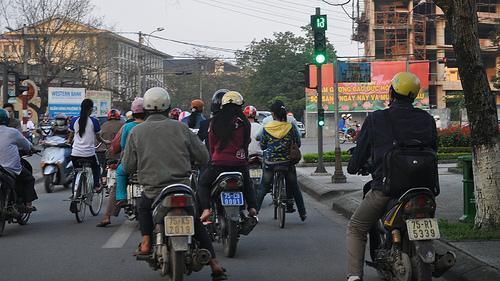How many round green lights are there?
Give a very brief answer. 2. 